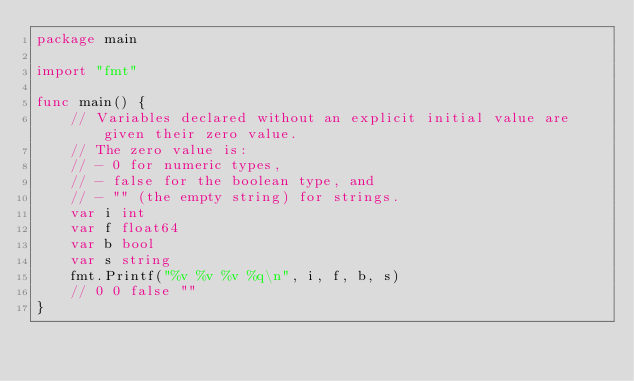Convert code to text. <code><loc_0><loc_0><loc_500><loc_500><_Go_>package main

import "fmt"

func main() {
	// Variables declared without an explicit initial value are given their zero value.
	// The zero value is:
	// - 0 for numeric types,
	// - false for the boolean type, and
	// - "" (the empty string) for strings.
	var i int
	var f float64
	var b bool
	var s string
	fmt.Printf("%v %v %v %q\n", i, f, b, s)
	// 0 0 false ""
}
</code> 